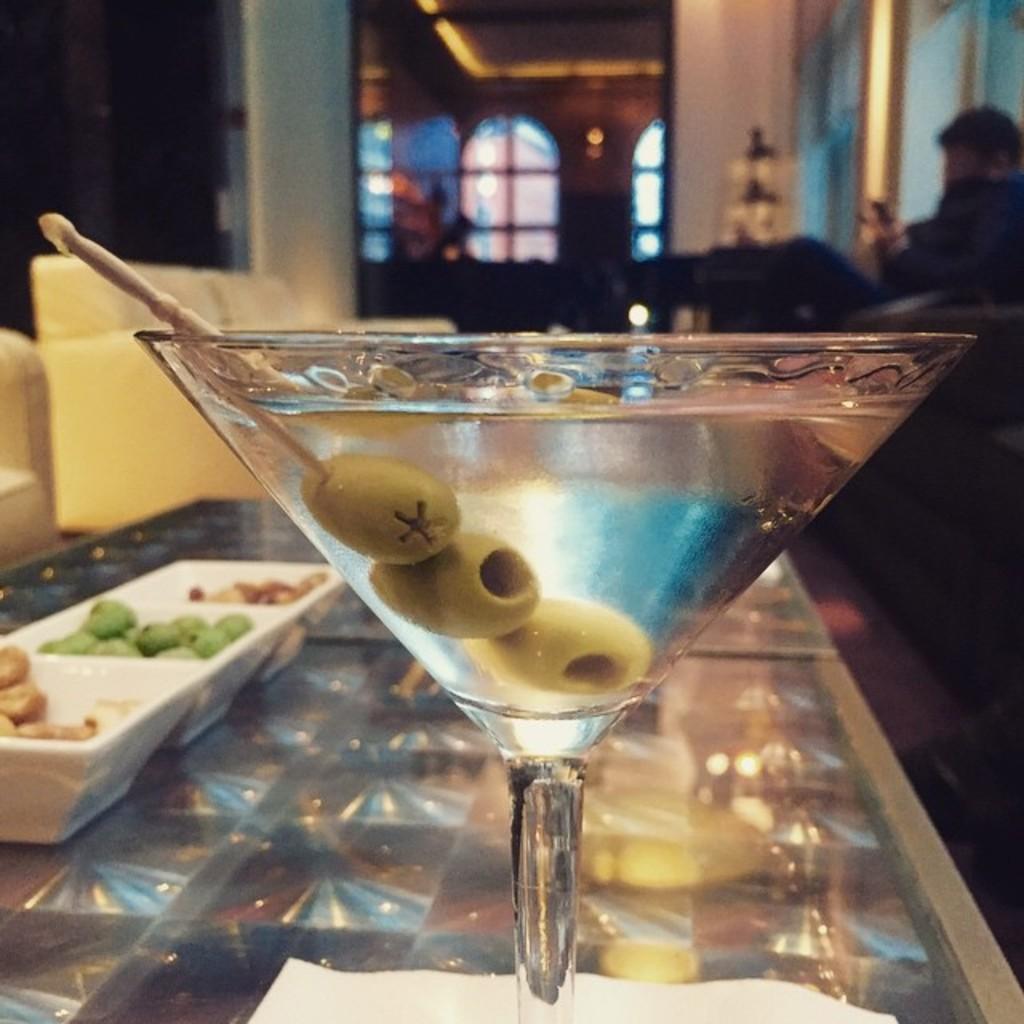Can you describe this image briefly? In this image we can see a drink which is in glass and there are some food items in the tray which is on the glass table and in the background of the image there is a person sitting on a couch and there is a glass door. 